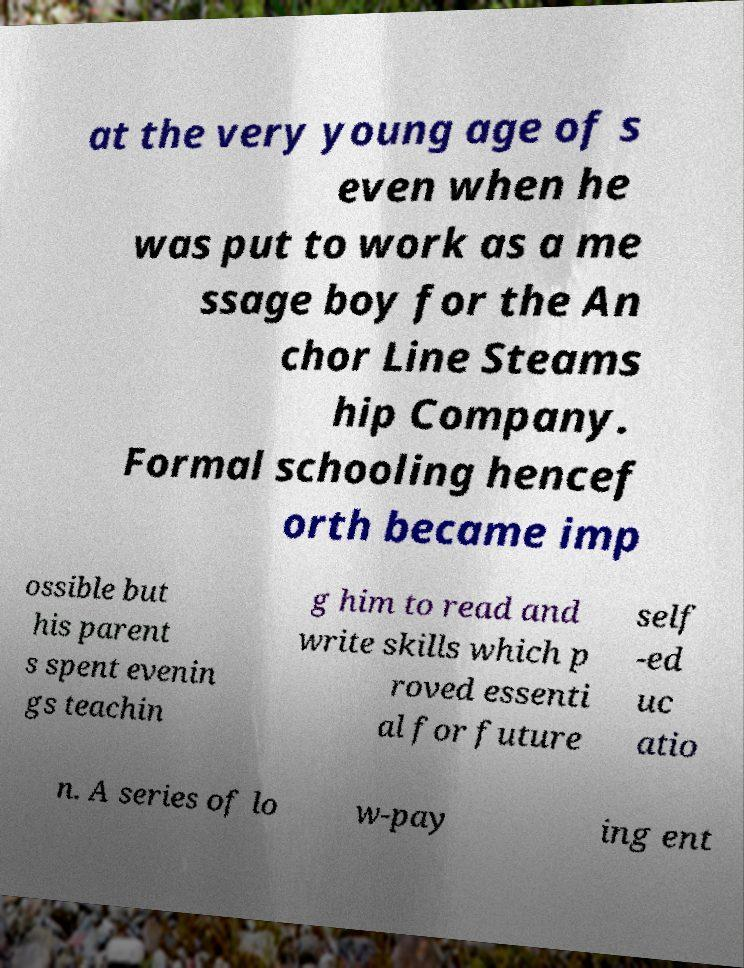What messages or text are displayed in this image? I need them in a readable, typed format. at the very young age of s even when he was put to work as a me ssage boy for the An chor Line Steams hip Company. Formal schooling hencef orth became imp ossible but his parent s spent evenin gs teachin g him to read and write skills which p roved essenti al for future self -ed uc atio n. A series of lo w-pay ing ent 